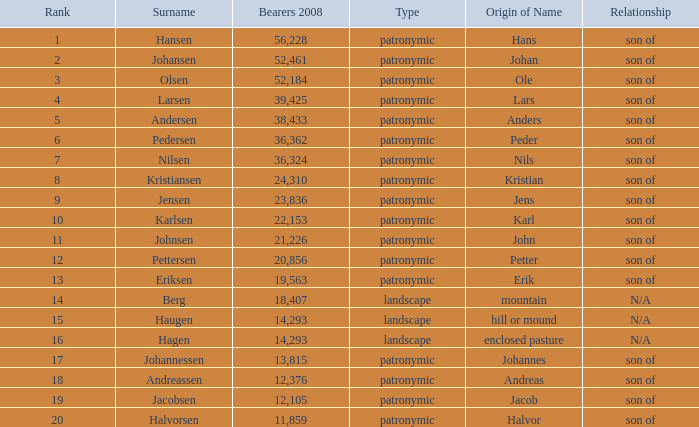What is the highest Number of Bearers 2008, when Surname is Hansen, and when Rank is less than 1? None. 